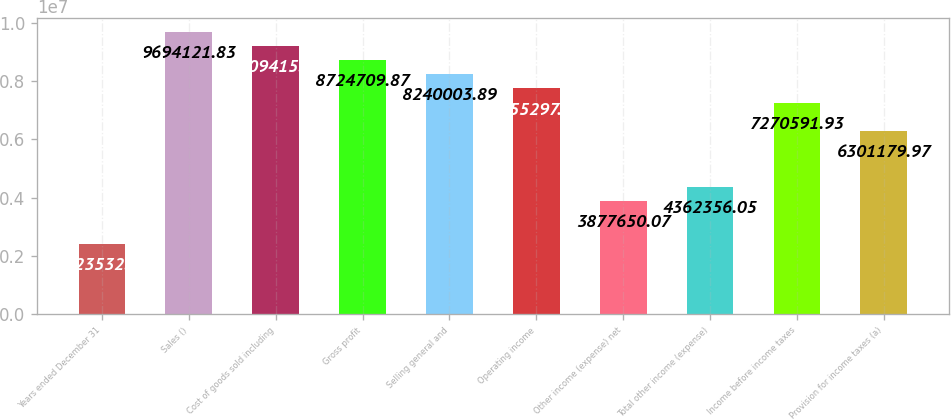Convert chart. <chart><loc_0><loc_0><loc_500><loc_500><bar_chart><fcel>Years ended December 31<fcel>Sales ()<fcel>Cost of goods sold including<fcel>Gross profit<fcel>Selling general and<fcel>Operating income<fcel>Other income (expense) net<fcel>Total other income (expense)<fcel>Income before income taxes<fcel>Provision for income taxes (a)<nl><fcel>2.42353e+06<fcel>9.69412e+06<fcel>9.20942e+06<fcel>8.72471e+06<fcel>8.24e+06<fcel>7.7553e+06<fcel>3.87765e+06<fcel>4.36236e+06<fcel>7.27059e+06<fcel>6.30118e+06<nl></chart> 